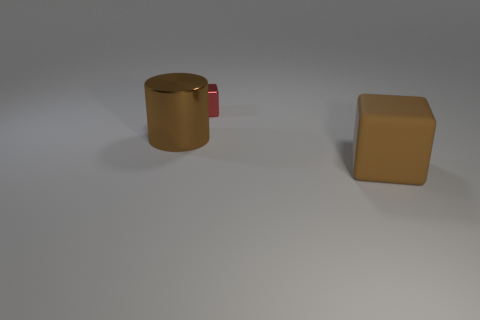Add 2 brown cylinders. How many objects exist? 5 Subtract all blocks. How many objects are left? 1 Subtract all metallic blocks. Subtract all metallic things. How many objects are left? 0 Add 2 brown metal cylinders. How many brown metal cylinders are left? 3 Add 3 cylinders. How many cylinders exist? 4 Subtract 0 red balls. How many objects are left? 3 